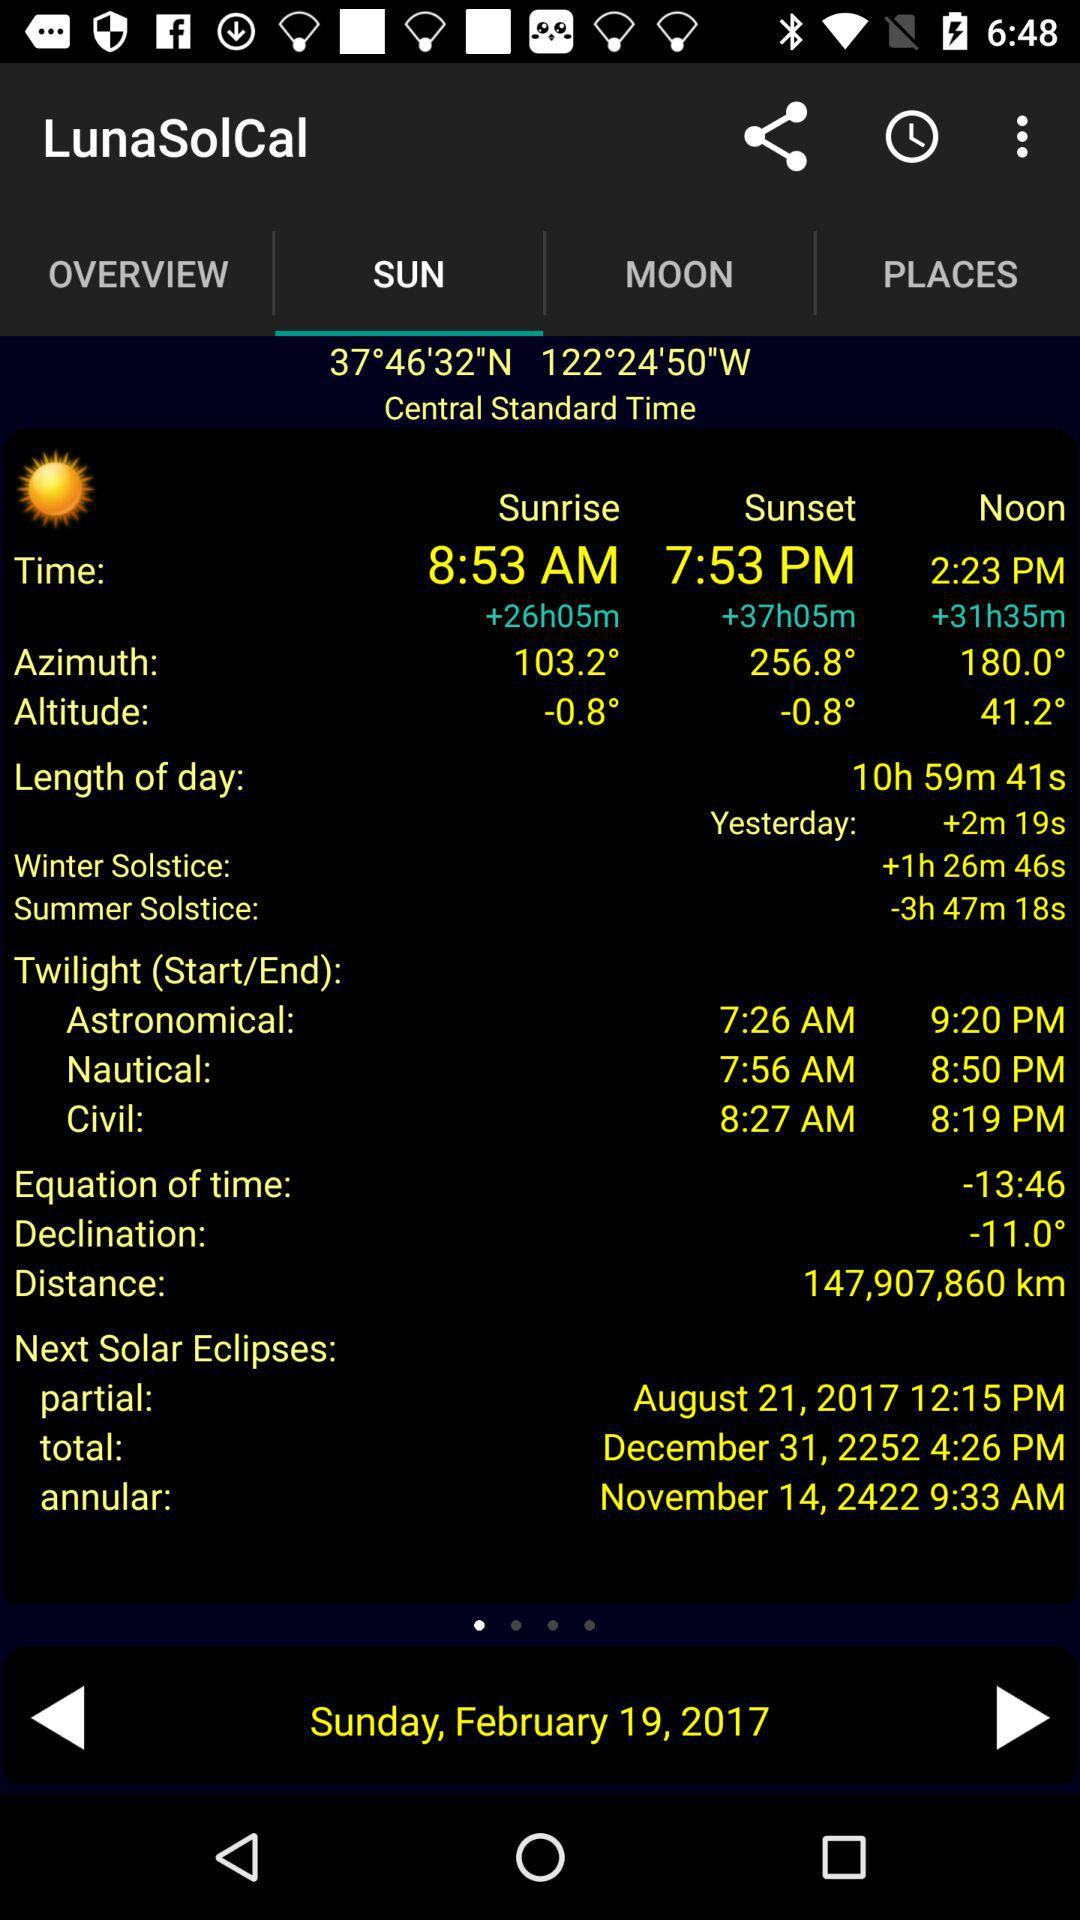What is the length of the day? The length of the day is 10 hours, 59 minutes and 41 seconds. 